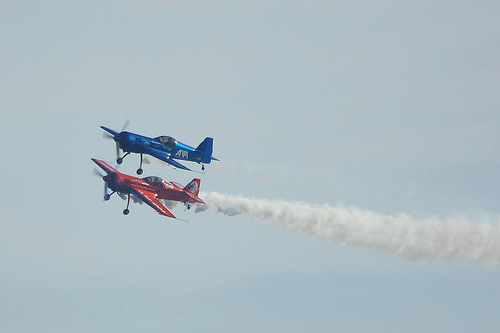How many of the airplanes have entrails? In the image, one of the airplanes is shown with a visible trail of smoke or 'entrails' behind it. 